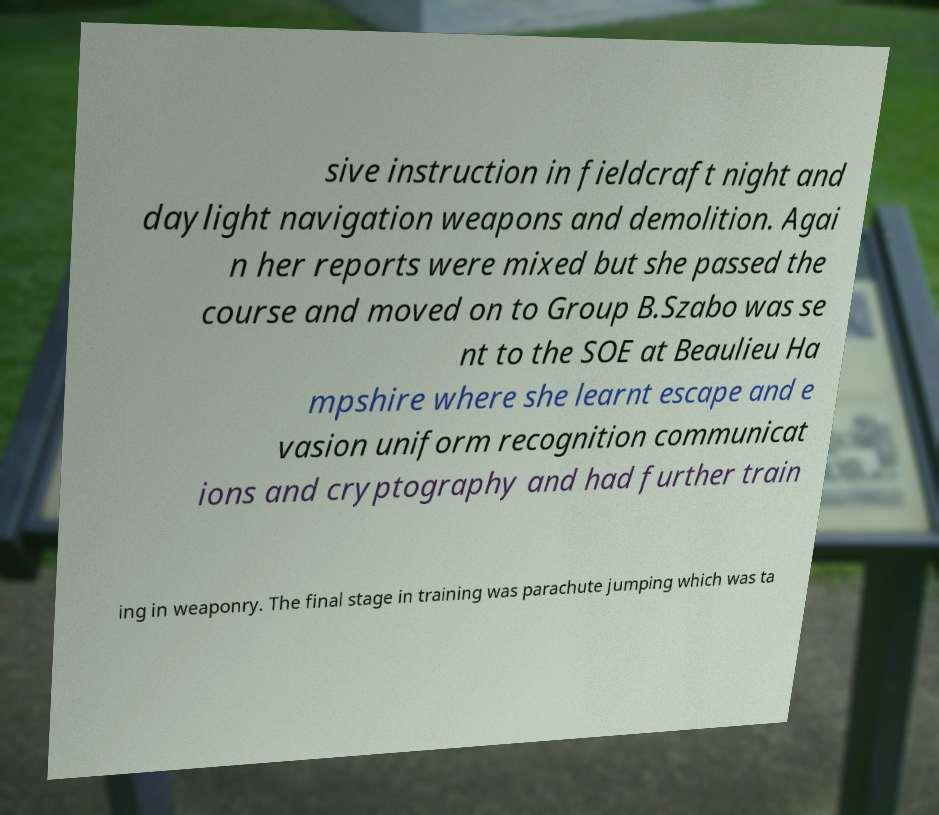For documentation purposes, I need the text within this image transcribed. Could you provide that? sive instruction in fieldcraft night and daylight navigation weapons and demolition. Agai n her reports were mixed but she passed the course and moved on to Group B.Szabo was se nt to the SOE at Beaulieu Ha mpshire where she learnt escape and e vasion uniform recognition communicat ions and cryptography and had further train ing in weaponry. The final stage in training was parachute jumping which was ta 